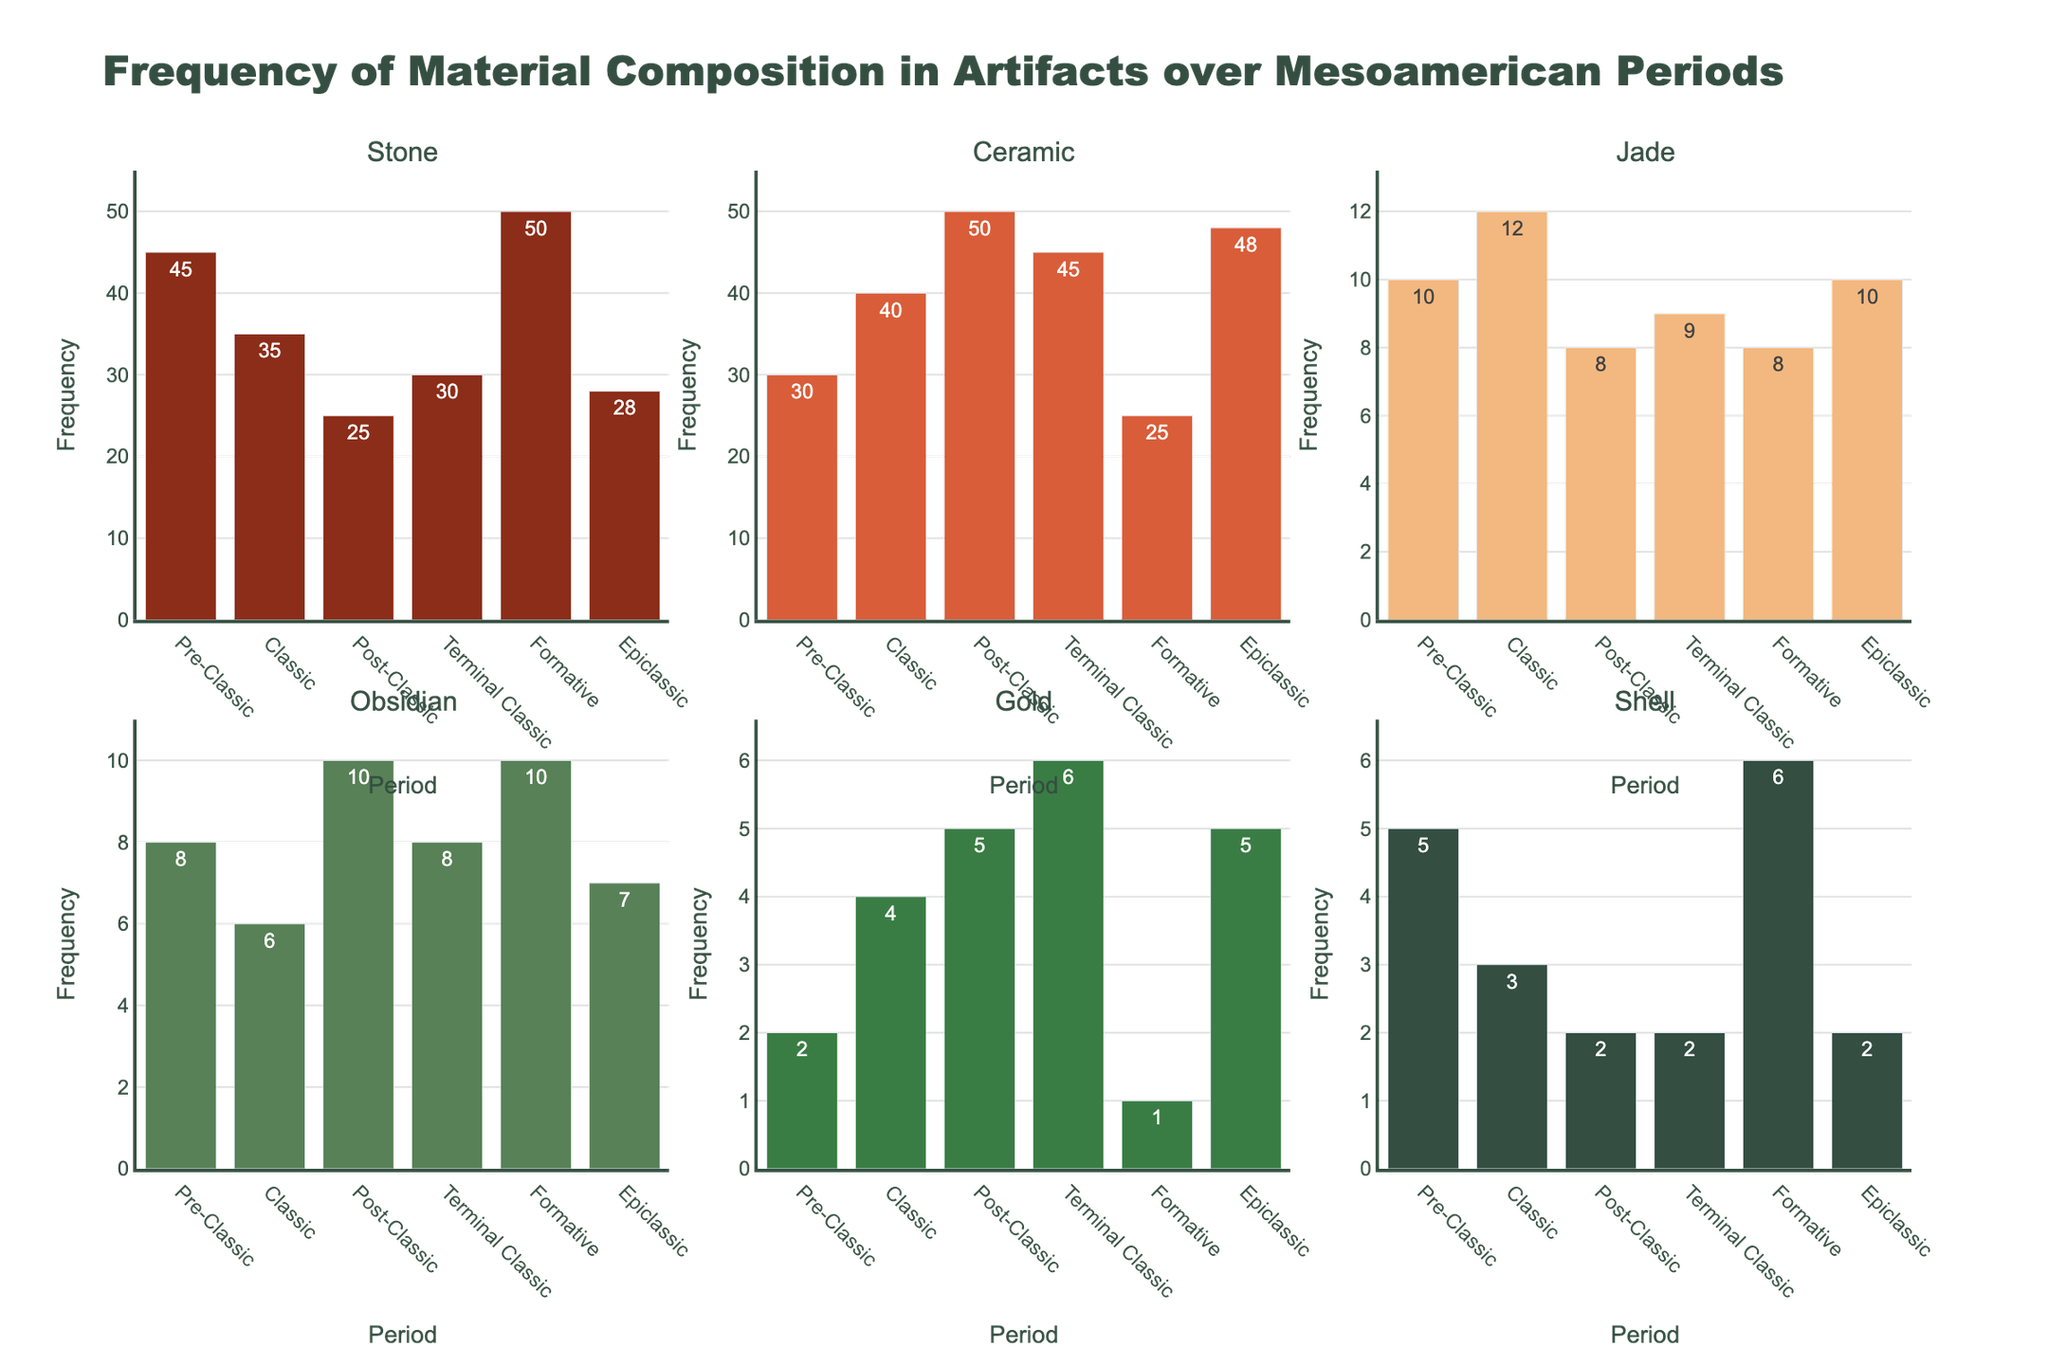What is the title of the figure? The title is located at the top of the figure, providing a general description of what the figure represents.
Answer: Frequency of Material Composition in Artifacts over Mesoamerican Periods What period shows the highest frequency of Stone artifacts? Looking at the bar representing Stone across different periods, the height of the bar for the Formative period is the tallest.
Answer: Formative How many more Ceramic artifacts were found in the Post-Classic period compared to the Pre-Classic period? Subtract the frequency of Ceramic artifacts in the Pre-Classic period (30) from the frequency in the Post-Classic period (50).
Answer: 20 Which material shows the least variation in frequency across all periods? By comparing the range of frequencies for each material, Shell exhibits the least fluctuation from 2 to 6.
Answer: Shell What is the median frequency of Obsidian artifacts across all periods? Arrange the frequencies of Obsidian artifacts in order: [6, 7, 8, 8, 8, 10]. The median is the average of the two middle numbers (8 and 8).
Answer: 8 During which period was Gold most prominently used in artifacts? Gold artifacts are shown by the yellow bars; the tallest yellow bar appears in the Terminal Classic period.
Answer: Terminal Classic Which material has a decreasing trend in usage from the Formative to the Post-Classic period? Observe the bar heights for each material from the Formative to the Post-Classic periods; Stone decreases from 50 to 25, showing a downward trend.
Answer: Stone How much does the frequency of Stone artifacts in the Pre-Classic period exceed the frequency of Shell artifacts in the same period? Subtract the frequency of Shell (5) from the frequency of Stone (45) in the Pre-Classic period.
Answer: 40 Who has the greatest range of frequency values across all periods, Stone or Ceramic? Find the range for both:
- Stone: Max (50) - Min (25) = 25
- Ceramic: Max (50) - Min (25) = 25
Both materials have the same range.
Answer: Both 